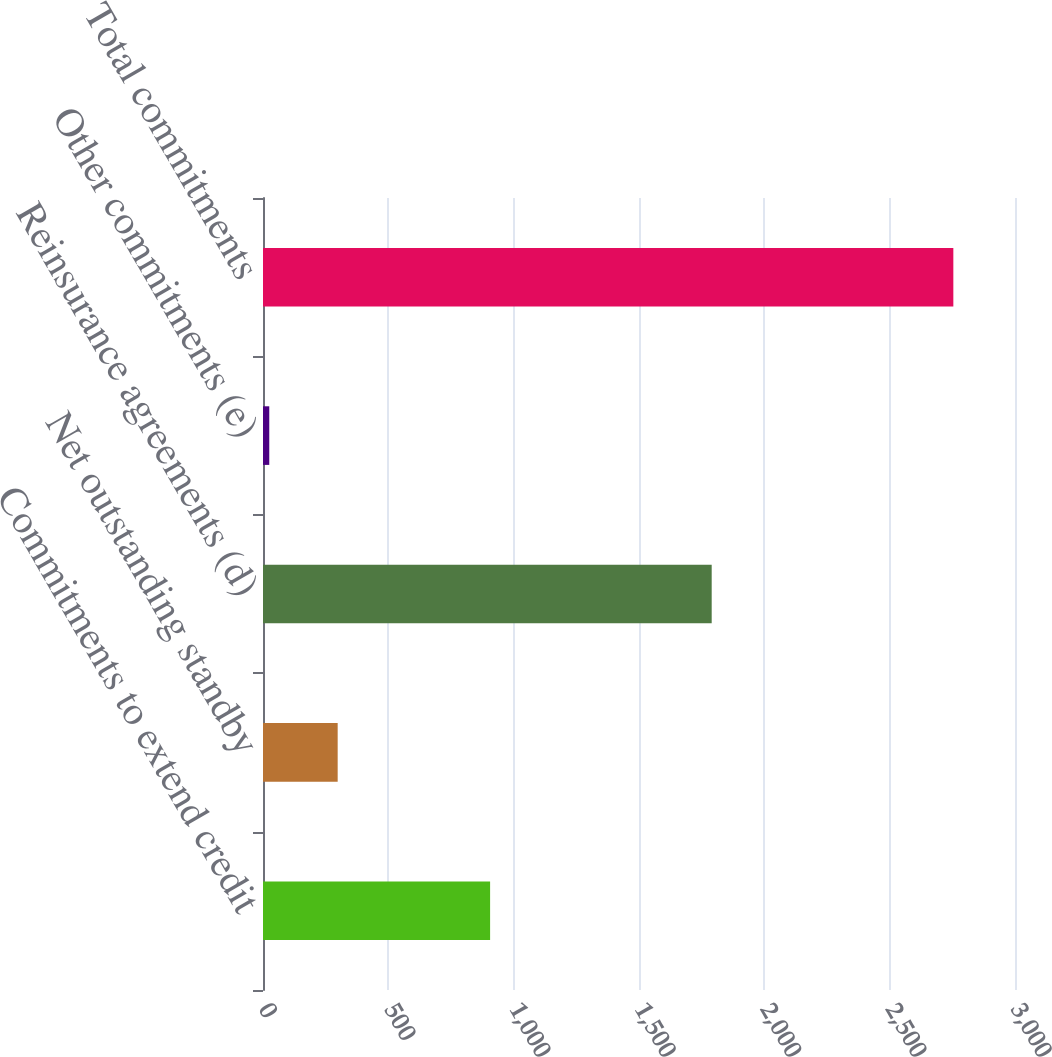Convert chart. <chart><loc_0><loc_0><loc_500><loc_500><bar_chart><fcel>Commitments to extend credit<fcel>Net outstanding standby<fcel>Reinsurance agreements (d)<fcel>Other commitments (e)<fcel>Total commitments<nl><fcel>906<fcel>297.9<fcel>1790<fcel>25<fcel>2754<nl></chart> 